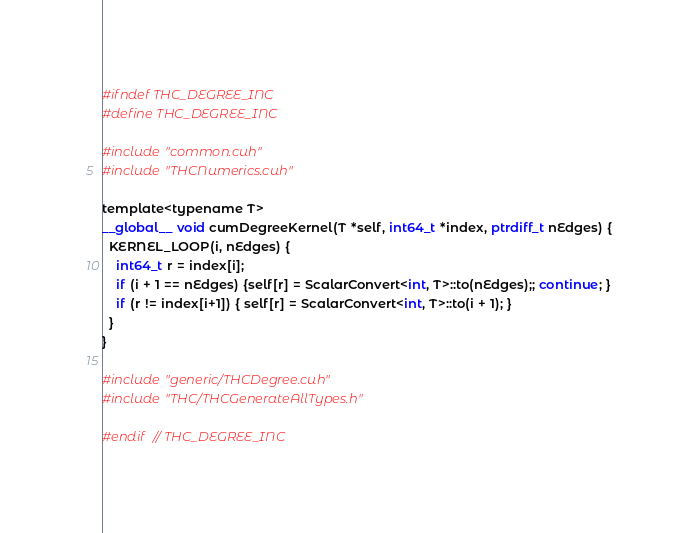<code> <loc_0><loc_0><loc_500><loc_500><_Cuda_>#ifndef THC_DEGREE_INC
#define THC_DEGREE_INC

#include "common.cuh"
#include "THCNumerics.cuh"

template<typename T>
__global__ void cumDegreeKernel(T *self, int64_t *index, ptrdiff_t nEdges) {
  KERNEL_LOOP(i, nEdges) {
    int64_t r = index[i];
    if (i + 1 == nEdges) {self[r] = ScalarConvert<int, T>::to(nEdges);; continue; }
    if (r != index[i+1]) { self[r] = ScalarConvert<int, T>::to(i + 1); }
  }
}

#include "generic/THCDegree.cuh"
#include "THC/THCGenerateAllTypes.h"

#endif  // THC_DEGREE_INC
</code> 